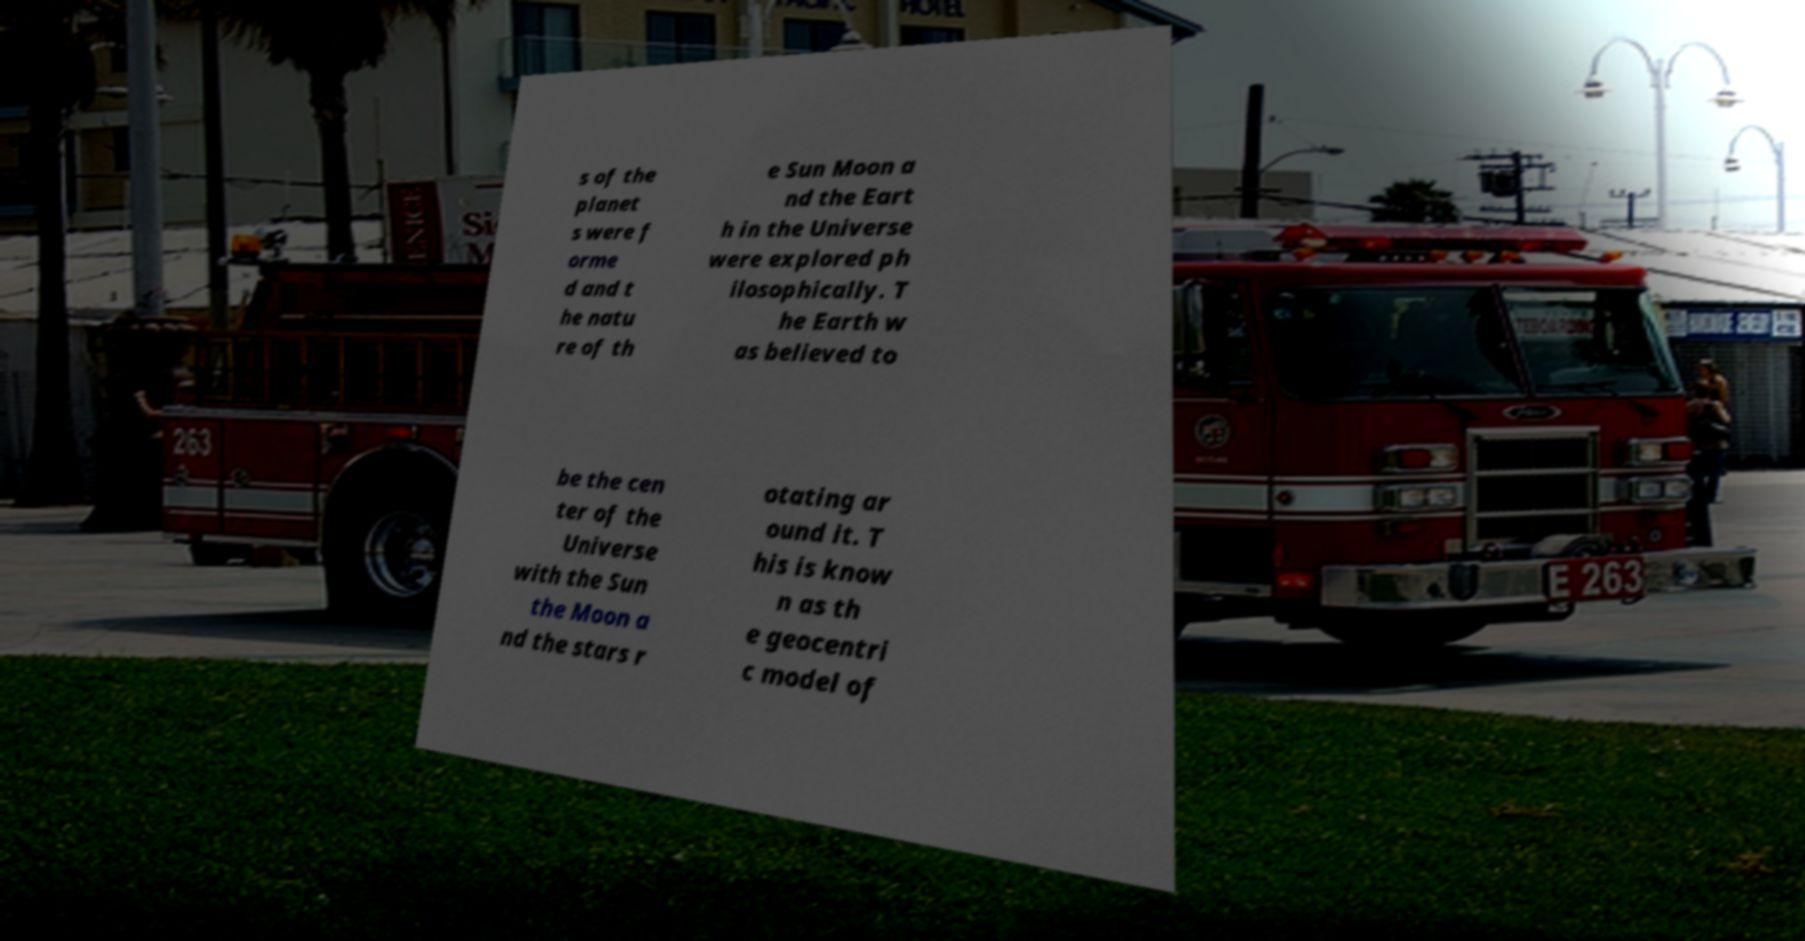What messages or text are displayed in this image? I need them in a readable, typed format. s of the planet s were f orme d and t he natu re of th e Sun Moon a nd the Eart h in the Universe were explored ph ilosophically. T he Earth w as believed to be the cen ter of the Universe with the Sun the Moon a nd the stars r otating ar ound it. T his is know n as th e geocentri c model of 